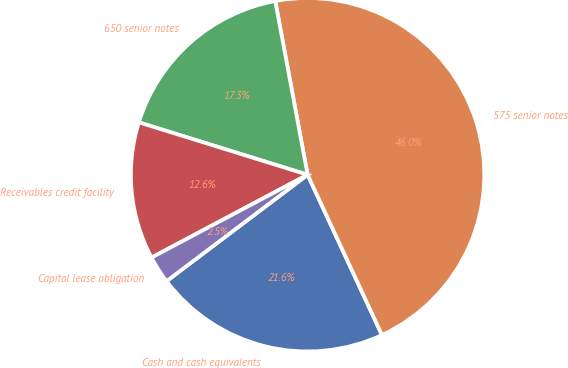Convert chart to OTSL. <chart><loc_0><loc_0><loc_500><loc_500><pie_chart><fcel>Cash and cash equivalents<fcel>575 senior notes<fcel>650 senior notes<fcel>Receivables credit facility<fcel>Capital lease obligation<nl><fcel>21.63%<fcel>46.02%<fcel>17.28%<fcel>12.56%<fcel>2.52%<nl></chart> 